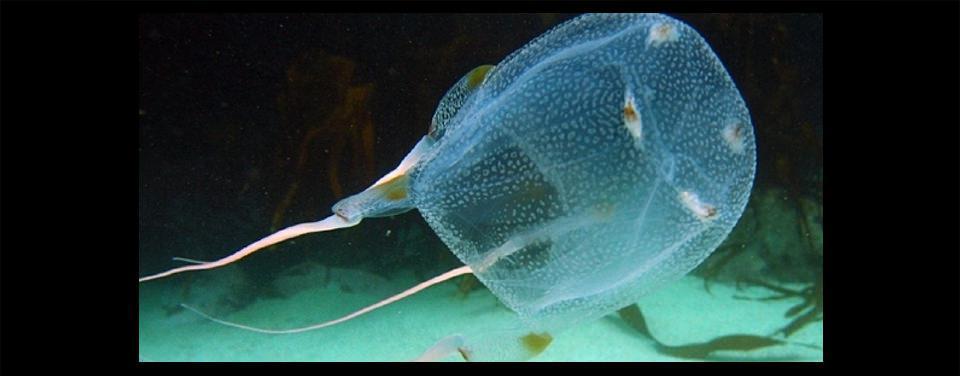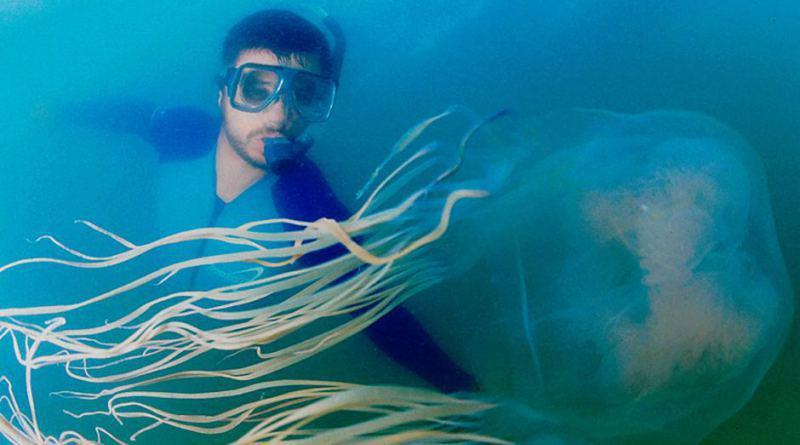The first image is the image on the left, the second image is the image on the right. Evaluate the accuracy of this statement regarding the images: "There are exactly two jellyfish and no humans, and at least one jellyfish is facing to the right.". Is it true? Answer yes or no. No. 